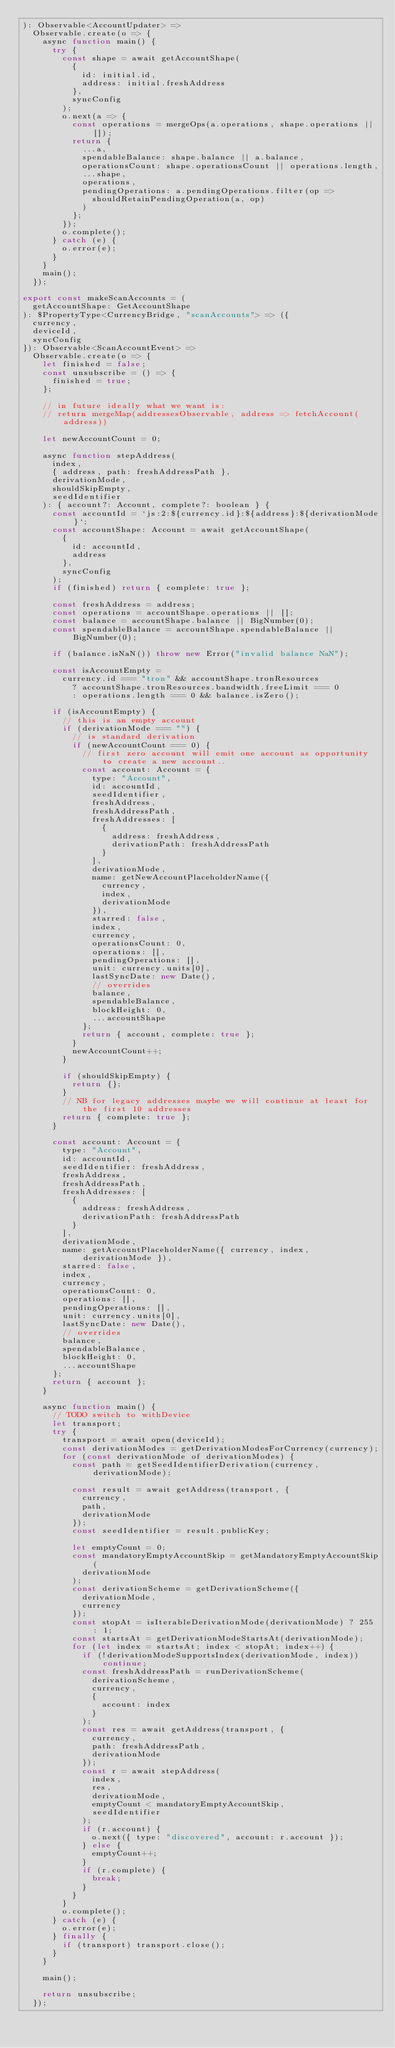<code> <loc_0><loc_0><loc_500><loc_500><_JavaScript_>): Observable<AccountUpdater> =>
  Observable.create(o => {
    async function main() {
      try {
        const shape = await getAccountShape(
          {
            id: initial.id,
            address: initial.freshAddress
          },
          syncConfig
        );
        o.next(a => {
          const operations = mergeOps(a.operations, shape.operations || []);
          return {
            ...a,
            spendableBalance: shape.balance || a.balance,
            operationsCount: shape.operationsCount || operations.length,
            ...shape,
            operations,
            pendingOperations: a.pendingOperations.filter(op =>
              shouldRetainPendingOperation(a, op)
            )
          };
        });
        o.complete();
      } catch (e) {
        o.error(e);
      }
    }
    main();
  });

export const makeScanAccounts = (
  getAccountShape: GetAccountShape
): $PropertyType<CurrencyBridge, "scanAccounts"> => ({
  currency,
  deviceId,
  syncConfig
}): Observable<ScanAccountEvent> =>
  Observable.create(o => {
    let finished = false;
    const unsubscribe = () => {
      finished = true;
    };

    // in future ideally what we want is:
    // return mergeMap(addressesObservable, address => fetchAccount(address))

    let newAccountCount = 0;

    async function stepAddress(
      index,
      { address, path: freshAddressPath },
      derivationMode,
      shouldSkipEmpty,
      seedIdentifier
    ): { account?: Account, complete?: boolean } {
      const accountId = `js:2:${currency.id}:${address}:${derivationMode}`;
      const accountShape: Account = await getAccountShape(
        {
          id: accountId,
          address
        },
        syncConfig
      );
      if (finished) return { complete: true };

      const freshAddress = address;
      const operations = accountShape.operations || [];
      const balance = accountShape.balance || BigNumber(0);
      const spendableBalance = accountShape.spendableBalance || BigNumber(0);

      if (balance.isNaN()) throw new Error("invalid balance NaN");

      const isAccountEmpty =
        currency.id === "tron" && accountShape.tronResources
          ? accountShape.tronResources.bandwidth.freeLimit === 0
          : operations.length === 0 && balance.isZero();

      if (isAccountEmpty) {
        // this is an empty account
        if (derivationMode === "") {
          // is standard derivation
          if (newAccountCount === 0) {
            // first zero account will emit one account as opportunity to create a new account..
            const account: Account = {
              type: "Account",
              id: accountId,
              seedIdentifier,
              freshAddress,
              freshAddressPath,
              freshAddresses: [
                {
                  address: freshAddress,
                  derivationPath: freshAddressPath
                }
              ],
              derivationMode,
              name: getNewAccountPlaceholderName({
                currency,
                index,
                derivationMode
              }),
              starred: false,
              index,
              currency,
              operationsCount: 0,
              operations: [],
              pendingOperations: [],
              unit: currency.units[0],
              lastSyncDate: new Date(),
              // overrides
              balance,
              spendableBalance,
              blockHeight: 0,
              ...accountShape
            };
            return { account, complete: true };
          }
          newAccountCount++;
        }

        if (shouldSkipEmpty) {
          return {};
        }
        // NB for legacy addresses maybe we will continue at least for the first 10 addresses
        return { complete: true };
      }

      const account: Account = {
        type: "Account",
        id: accountId,
        seedIdentifier: freshAddress,
        freshAddress,
        freshAddressPath,
        freshAddresses: [
          {
            address: freshAddress,
            derivationPath: freshAddressPath
          }
        ],
        derivationMode,
        name: getAccountPlaceholderName({ currency, index, derivationMode }),
        starred: false,
        index,
        currency,
        operationsCount: 0,
        operations: [],
        pendingOperations: [],
        unit: currency.units[0],
        lastSyncDate: new Date(),
        // overrides
        balance,
        spendableBalance,
        blockHeight: 0,
        ...accountShape
      };
      return { account };
    }

    async function main() {
      // TODO switch to withDevice
      let transport;
      try {
        transport = await open(deviceId);
        const derivationModes = getDerivationModesForCurrency(currency);
        for (const derivationMode of derivationModes) {
          const path = getSeedIdentifierDerivation(currency, derivationMode);

          const result = await getAddress(transport, {
            currency,
            path,
            derivationMode
          });
          const seedIdentifier = result.publicKey;

          let emptyCount = 0;
          const mandatoryEmptyAccountSkip = getMandatoryEmptyAccountSkip(
            derivationMode
          );
          const derivationScheme = getDerivationScheme({
            derivationMode,
            currency
          });
          const stopAt = isIterableDerivationMode(derivationMode) ? 255 : 1;
          const startsAt = getDerivationModeStartsAt(derivationMode);
          for (let index = startsAt; index < stopAt; index++) {
            if (!derivationModeSupportsIndex(derivationMode, index)) continue;
            const freshAddressPath = runDerivationScheme(
              derivationScheme,
              currency,
              {
                account: index
              }
            );
            const res = await getAddress(transport, {
              currency,
              path: freshAddressPath,
              derivationMode
            });
            const r = await stepAddress(
              index,
              res,
              derivationMode,
              emptyCount < mandatoryEmptyAccountSkip,
              seedIdentifier
            );
            if (r.account) {
              o.next({ type: "discovered", account: r.account });
            } else {
              emptyCount++;
            }
            if (r.complete) {
              break;
            }
          }
        }
        o.complete();
      } catch (e) {
        o.error(e);
      } finally {
        if (transport) transport.close();
      }
    }

    main();

    return unsubscribe;
  });
</code> 